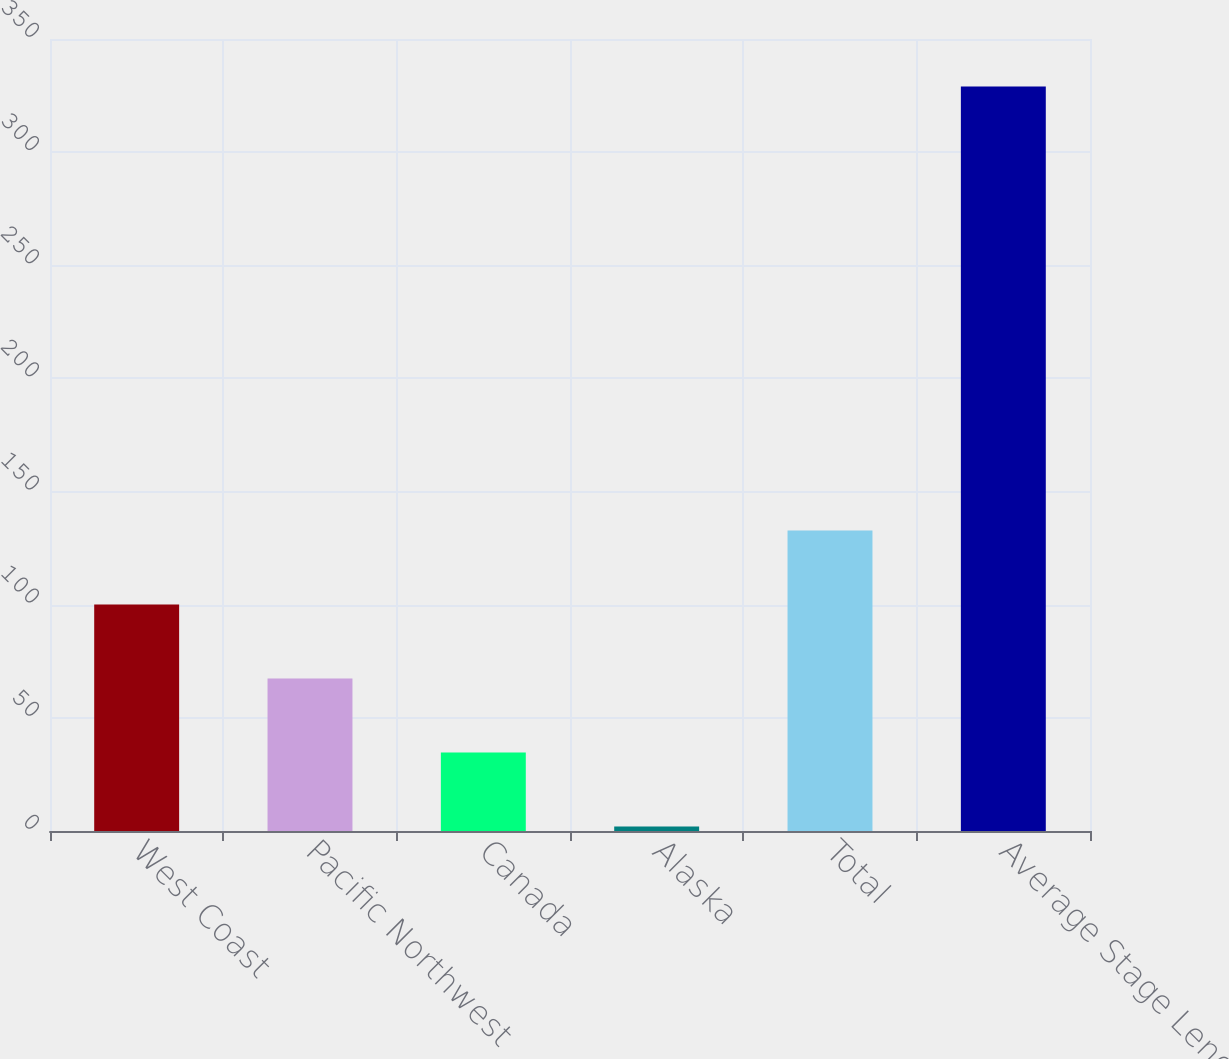Convert chart. <chart><loc_0><loc_0><loc_500><loc_500><bar_chart><fcel>West Coast<fcel>Pacific Northwest<fcel>Canada<fcel>Alaska<fcel>Total<fcel>Average Stage Length<nl><fcel>100.1<fcel>67.4<fcel>34.7<fcel>2<fcel>132.8<fcel>329<nl></chart> 